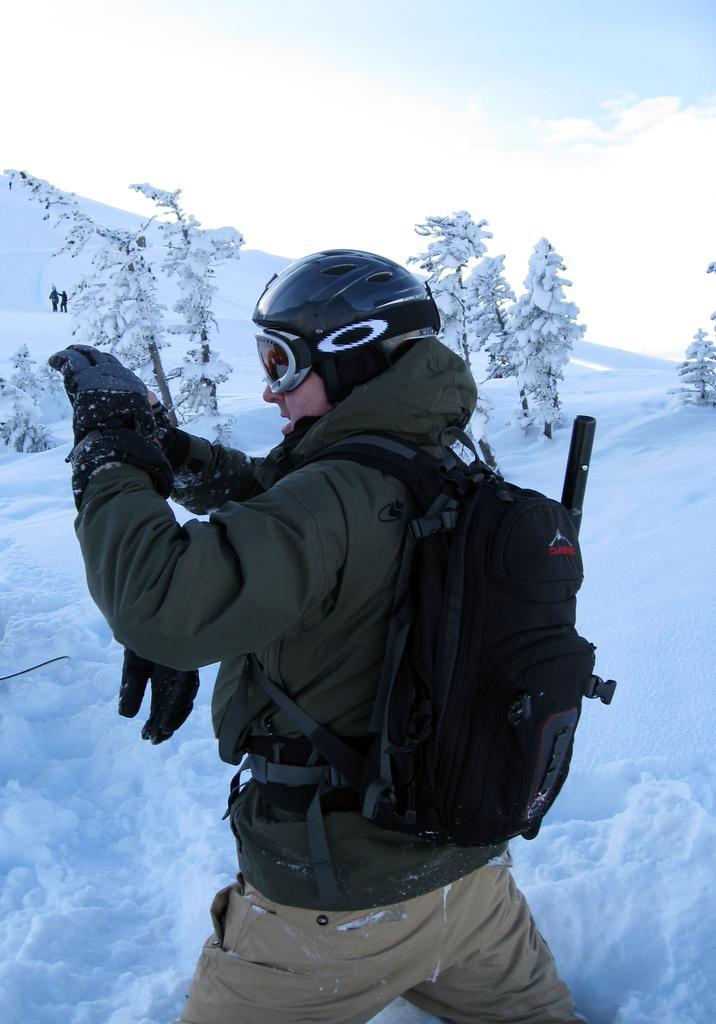What is the main subject of the image? There is a man standing in the center of the image. What is the man wearing? The man is wearing a jacket and a helmet on his head. What can be seen in the background of the image? There is snow, a tree, and the sky visible in the background. What is the condition of the sky in the image? The sky is visible in the background, and it has clouds. What type of stitch is being used to sew the country in the image? There is no country or stitching present in the image; it features a man wearing a jacket and helmet in a snowy background. What invention is being demonstrated by the man in the image? There is no invention being demonstrated by the man in the image; he is simply standing in the snow with a jacket and helmet. 